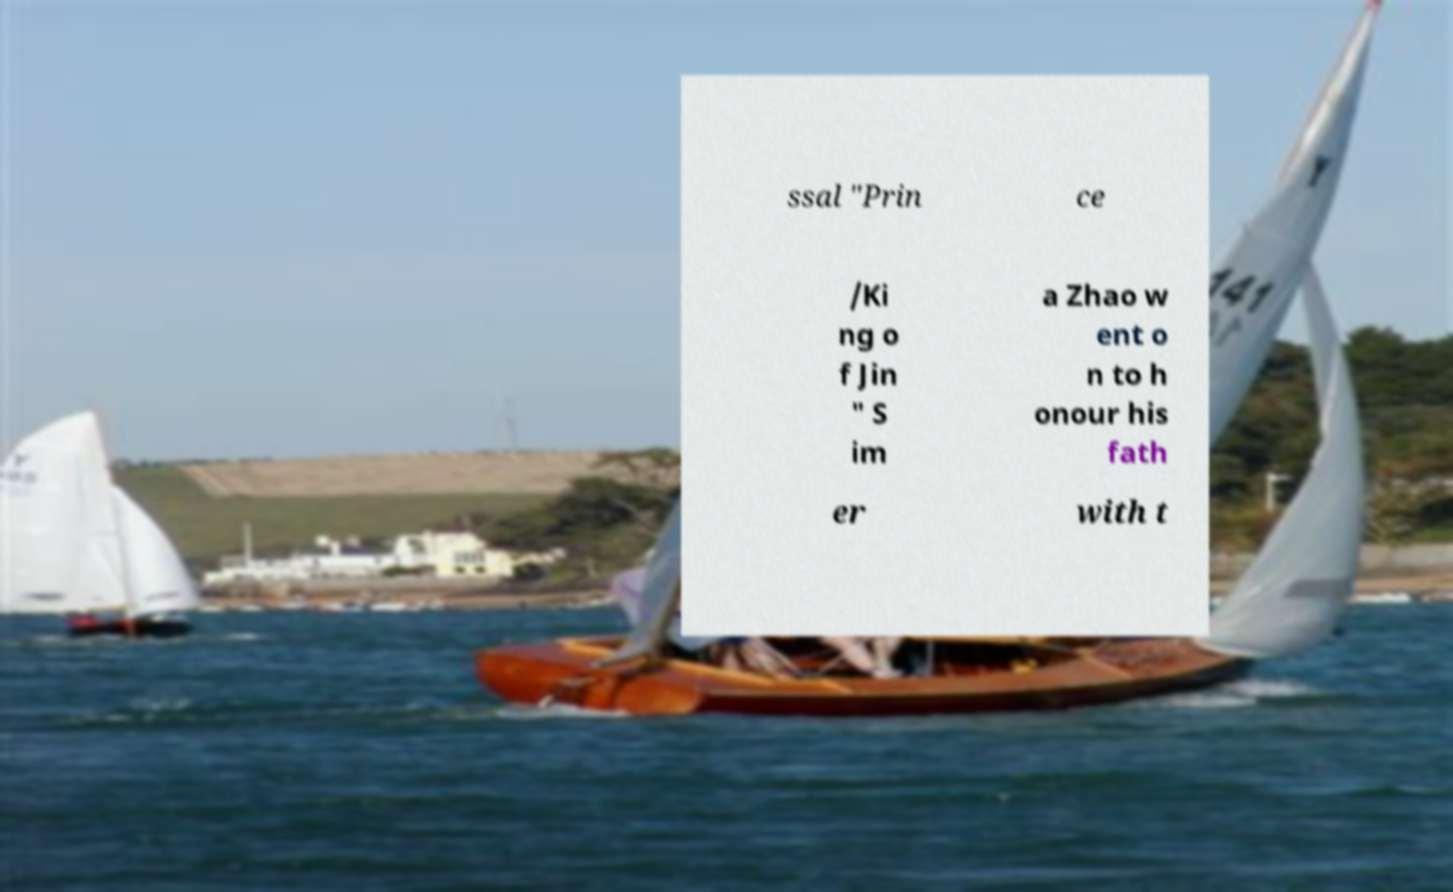There's text embedded in this image that I need extracted. Can you transcribe it verbatim? ssal "Prin ce /Ki ng o f Jin " S im a Zhao w ent o n to h onour his fath er with t 